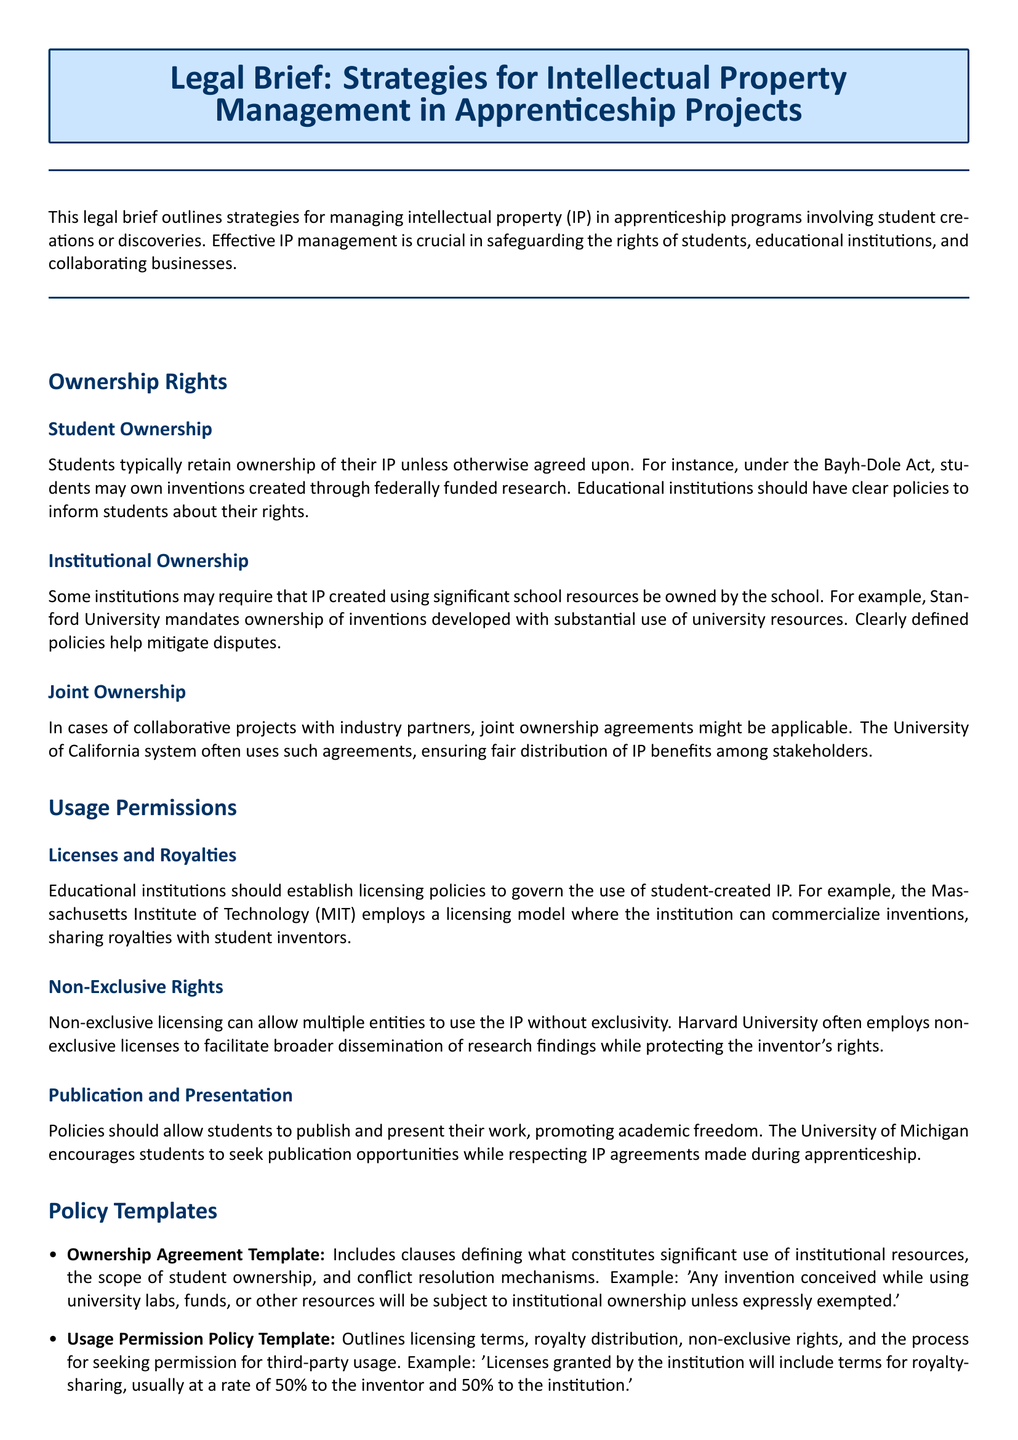what is the primary focus of the legal brief? The brief outlines strategies for managing intellectual property in apprenticeship programs involving student creations or discoveries.
Answer: strategies for managing intellectual property which act allows students to own inventions created through federally funded research? The Bayh-Dole Act permits students ownership of inventions in this context.
Answer: Bayh-Dole Act what type of ownership agreement does Stanford University mandate? Stanford University requires ownership of inventions developed with substantial use of university resources.
Answer: institutional ownership what is a common licensing model employed by MIT? MIT employs a licensing model where the institution can commercialize inventions, sharing royalties with student inventors.
Answer: licensing model how are royalties typically shared according to the usage permission policy template? The template indicates royalties are usually shared at a rate of 50% to the inventor and 50% to the institution.
Answer: 50% to inventor, 50% to institution what is encouraged by the University of Michigan regarding student work? The University of Michigan encourages students to seek publication opportunities while respecting IP agreements made during apprenticeship.
Answer: seek publication opportunities what can enable multiple entities to use the IP without exclusivity? Non-exclusive licensing allows multiple entities to use the IP without exclusivity.
Answer: Non-exclusive licensing which institution's policy allows for broader dissemination of research findings? Harvard University's policy often employs non-exclusive licenses for wider dissemination.
Answer: Harvard University 